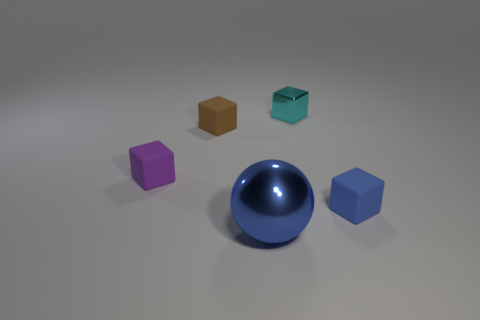How big is the object that is left of the small matte object behind the purple rubber object?
Give a very brief answer. Small. There is a shiny object behind the small block to the right of the metallic object that is behind the big blue thing; what size is it?
Offer a very short reply. Small. Does the thing on the right side of the cyan shiny object have the same shape as the thing behind the brown thing?
Offer a terse response. Yes. How many other objects are there of the same color as the ball?
Make the answer very short. 1. Do the cyan shiny object that is right of the sphere and the small blue block have the same size?
Ensure brevity in your answer.  Yes. Does the tiny block behind the brown rubber block have the same material as the small object in front of the small purple thing?
Offer a very short reply. No. Are there any metallic balls that have the same size as the purple rubber thing?
Offer a very short reply. No. There is a shiny thing that is behind the small rubber cube that is to the right of the blue thing to the left of the blue cube; what is its shape?
Your answer should be very brief. Cube. Is the number of cubes left of the tiny blue matte cube greater than the number of large balls?
Your answer should be very brief. Yes. Are there any tiny brown rubber things of the same shape as the tiny blue rubber object?
Your answer should be compact. Yes. 